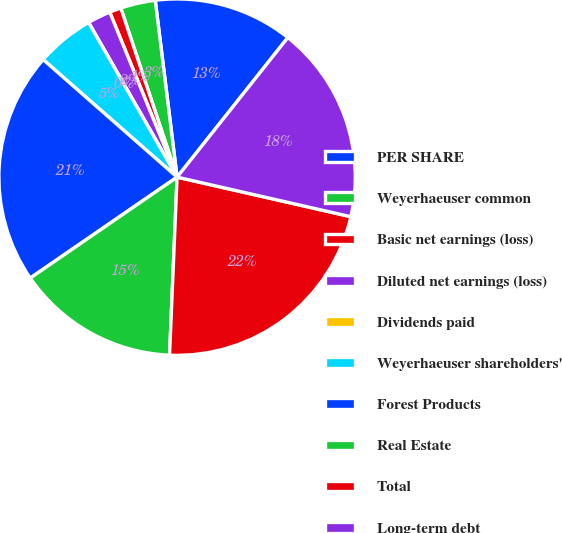<chart> <loc_0><loc_0><loc_500><loc_500><pie_chart><fcel>PER SHARE<fcel>Weyerhaeuser common<fcel>Basic net earnings (loss)<fcel>Diluted net earnings (loss)<fcel>Dividends paid<fcel>Weyerhaeuser shareholders'<fcel>Forest Products<fcel>Real Estate<fcel>Total<fcel>Long-term debt<nl><fcel>12.63%<fcel>3.16%<fcel>1.05%<fcel>2.11%<fcel>0.0%<fcel>5.26%<fcel>21.05%<fcel>14.74%<fcel>22.11%<fcel>17.89%<nl></chart> 